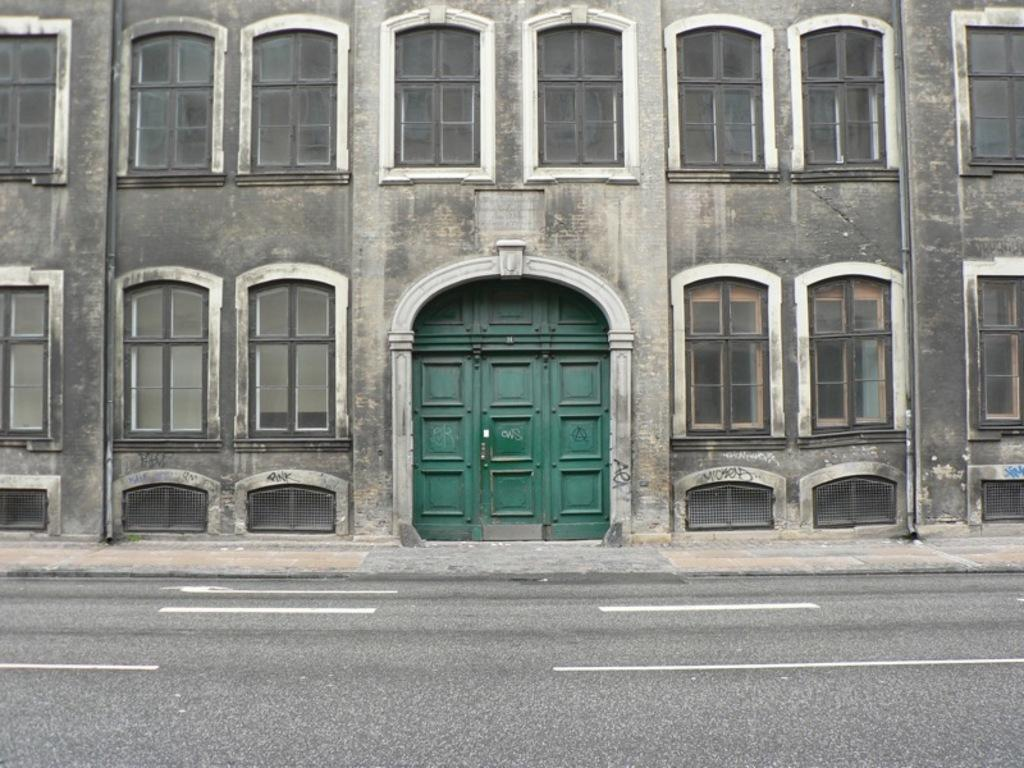What type of structure is visible in the image? There is a building in the image. What features can be seen on the building? The building has windows and a door. What is located in front of the building? There is a pavement in front of the building. What is beside the pavement? There is a road beside the pavement. What type of polish is being applied to the picture in the image? There is no picture or polish present in the image; it features a building with windows, a door, a pavement, and a road. 